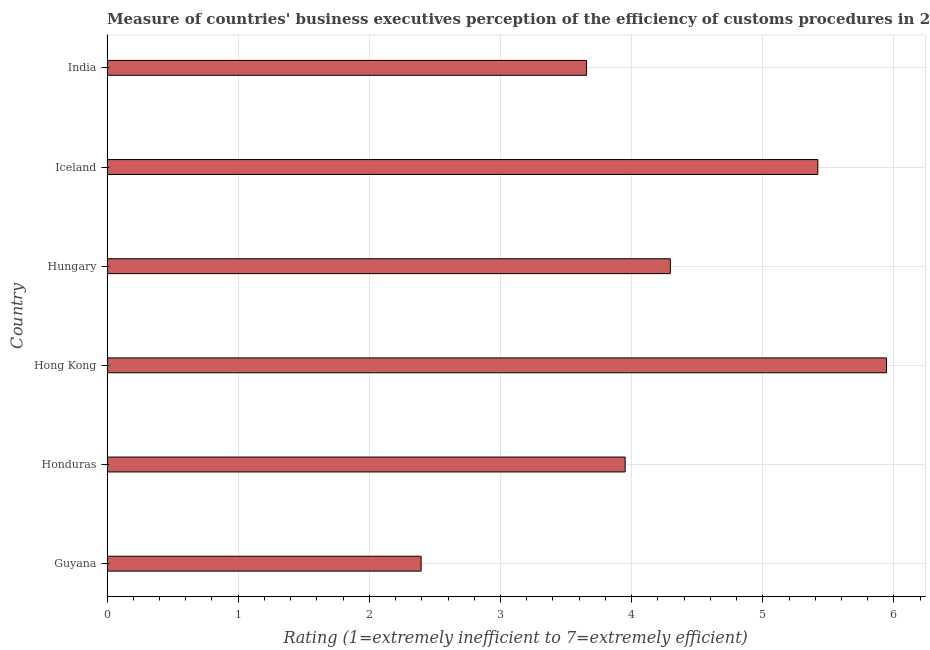What is the title of the graph?
Keep it short and to the point. Measure of countries' business executives perception of the efficiency of customs procedures in 2008. What is the label or title of the X-axis?
Provide a succinct answer. Rating (1=extremely inefficient to 7=extremely efficient). What is the rating measuring burden of customs procedure in Iceland?
Make the answer very short. 5.42. Across all countries, what is the maximum rating measuring burden of customs procedure?
Provide a succinct answer. 5.94. Across all countries, what is the minimum rating measuring burden of customs procedure?
Make the answer very short. 2.39. In which country was the rating measuring burden of customs procedure maximum?
Offer a terse response. Hong Kong. In which country was the rating measuring burden of customs procedure minimum?
Offer a terse response. Guyana. What is the sum of the rating measuring burden of customs procedure?
Make the answer very short. 25.66. What is the difference between the rating measuring burden of customs procedure in Hong Kong and India?
Your response must be concise. 2.29. What is the average rating measuring burden of customs procedure per country?
Keep it short and to the point. 4.28. What is the median rating measuring burden of customs procedure?
Give a very brief answer. 4.12. In how many countries, is the rating measuring burden of customs procedure greater than 1 ?
Make the answer very short. 6. What is the ratio of the rating measuring burden of customs procedure in Hong Kong to that in Hungary?
Make the answer very short. 1.38. Is the difference between the rating measuring burden of customs procedure in Guyana and Iceland greater than the difference between any two countries?
Provide a succinct answer. No. What is the difference between the highest and the second highest rating measuring burden of customs procedure?
Offer a very short reply. 0.52. What is the difference between the highest and the lowest rating measuring burden of customs procedure?
Keep it short and to the point. 3.55. In how many countries, is the rating measuring burden of customs procedure greater than the average rating measuring burden of customs procedure taken over all countries?
Your answer should be compact. 3. Are all the bars in the graph horizontal?
Your response must be concise. Yes. How many countries are there in the graph?
Keep it short and to the point. 6. Are the values on the major ticks of X-axis written in scientific E-notation?
Your response must be concise. No. What is the Rating (1=extremely inefficient to 7=extremely efficient) of Guyana?
Give a very brief answer. 2.39. What is the Rating (1=extremely inefficient to 7=extremely efficient) in Honduras?
Ensure brevity in your answer.  3.95. What is the Rating (1=extremely inefficient to 7=extremely efficient) of Hong Kong?
Offer a terse response. 5.94. What is the Rating (1=extremely inefficient to 7=extremely efficient) in Hungary?
Ensure brevity in your answer.  4.29. What is the Rating (1=extremely inefficient to 7=extremely efficient) of Iceland?
Offer a very short reply. 5.42. What is the Rating (1=extremely inefficient to 7=extremely efficient) of India?
Keep it short and to the point. 3.66. What is the difference between the Rating (1=extremely inefficient to 7=extremely efficient) in Guyana and Honduras?
Your response must be concise. -1.56. What is the difference between the Rating (1=extremely inefficient to 7=extremely efficient) in Guyana and Hong Kong?
Provide a succinct answer. -3.55. What is the difference between the Rating (1=extremely inefficient to 7=extremely efficient) in Guyana and Hungary?
Ensure brevity in your answer.  -1.9. What is the difference between the Rating (1=extremely inefficient to 7=extremely efficient) in Guyana and Iceland?
Keep it short and to the point. -3.02. What is the difference between the Rating (1=extremely inefficient to 7=extremely efficient) in Guyana and India?
Offer a very short reply. -1.26. What is the difference between the Rating (1=extremely inefficient to 7=extremely efficient) in Honduras and Hong Kong?
Make the answer very short. -1.99. What is the difference between the Rating (1=extremely inefficient to 7=extremely efficient) in Honduras and Hungary?
Ensure brevity in your answer.  -0.34. What is the difference between the Rating (1=extremely inefficient to 7=extremely efficient) in Honduras and Iceland?
Provide a short and direct response. -1.47. What is the difference between the Rating (1=extremely inefficient to 7=extremely efficient) in Honduras and India?
Offer a very short reply. 0.29. What is the difference between the Rating (1=extremely inefficient to 7=extremely efficient) in Hong Kong and Hungary?
Keep it short and to the point. 1.65. What is the difference between the Rating (1=extremely inefficient to 7=extremely efficient) in Hong Kong and Iceland?
Give a very brief answer. 0.52. What is the difference between the Rating (1=extremely inefficient to 7=extremely efficient) in Hong Kong and India?
Your response must be concise. 2.29. What is the difference between the Rating (1=extremely inefficient to 7=extremely efficient) in Hungary and Iceland?
Ensure brevity in your answer.  -1.12. What is the difference between the Rating (1=extremely inefficient to 7=extremely efficient) in Hungary and India?
Ensure brevity in your answer.  0.64. What is the difference between the Rating (1=extremely inefficient to 7=extremely efficient) in Iceland and India?
Ensure brevity in your answer.  1.76. What is the ratio of the Rating (1=extremely inefficient to 7=extremely efficient) in Guyana to that in Honduras?
Your answer should be compact. 0.61. What is the ratio of the Rating (1=extremely inefficient to 7=extremely efficient) in Guyana to that in Hong Kong?
Make the answer very short. 0.4. What is the ratio of the Rating (1=extremely inefficient to 7=extremely efficient) in Guyana to that in Hungary?
Offer a very short reply. 0.56. What is the ratio of the Rating (1=extremely inefficient to 7=extremely efficient) in Guyana to that in Iceland?
Offer a very short reply. 0.44. What is the ratio of the Rating (1=extremely inefficient to 7=extremely efficient) in Guyana to that in India?
Your response must be concise. 0.66. What is the ratio of the Rating (1=extremely inefficient to 7=extremely efficient) in Honduras to that in Hong Kong?
Your answer should be compact. 0.67. What is the ratio of the Rating (1=extremely inefficient to 7=extremely efficient) in Honduras to that in Hungary?
Your response must be concise. 0.92. What is the ratio of the Rating (1=extremely inefficient to 7=extremely efficient) in Honduras to that in Iceland?
Ensure brevity in your answer.  0.73. What is the ratio of the Rating (1=extremely inefficient to 7=extremely efficient) in Honduras to that in India?
Give a very brief answer. 1.08. What is the ratio of the Rating (1=extremely inefficient to 7=extremely efficient) in Hong Kong to that in Hungary?
Provide a short and direct response. 1.38. What is the ratio of the Rating (1=extremely inefficient to 7=extremely efficient) in Hong Kong to that in Iceland?
Your response must be concise. 1.1. What is the ratio of the Rating (1=extremely inefficient to 7=extremely efficient) in Hong Kong to that in India?
Keep it short and to the point. 1.63. What is the ratio of the Rating (1=extremely inefficient to 7=extremely efficient) in Hungary to that in Iceland?
Your answer should be compact. 0.79. What is the ratio of the Rating (1=extremely inefficient to 7=extremely efficient) in Hungary to that in India?
Ensure brevity in your answer.  1.18. What is the ratio of the Rating (1=extremely inefficient to 7=extremely efficient) in Iceland to that in India?
Your answer should be compact. 1.48. 